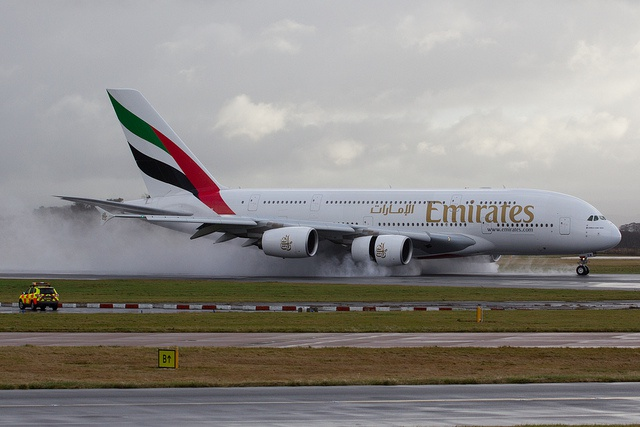Describe the objects in this image and their specific colors. I can see airplane in darkgray, black, and gray tones and car in darkgray, black, olive, and maroon tones in this image. 